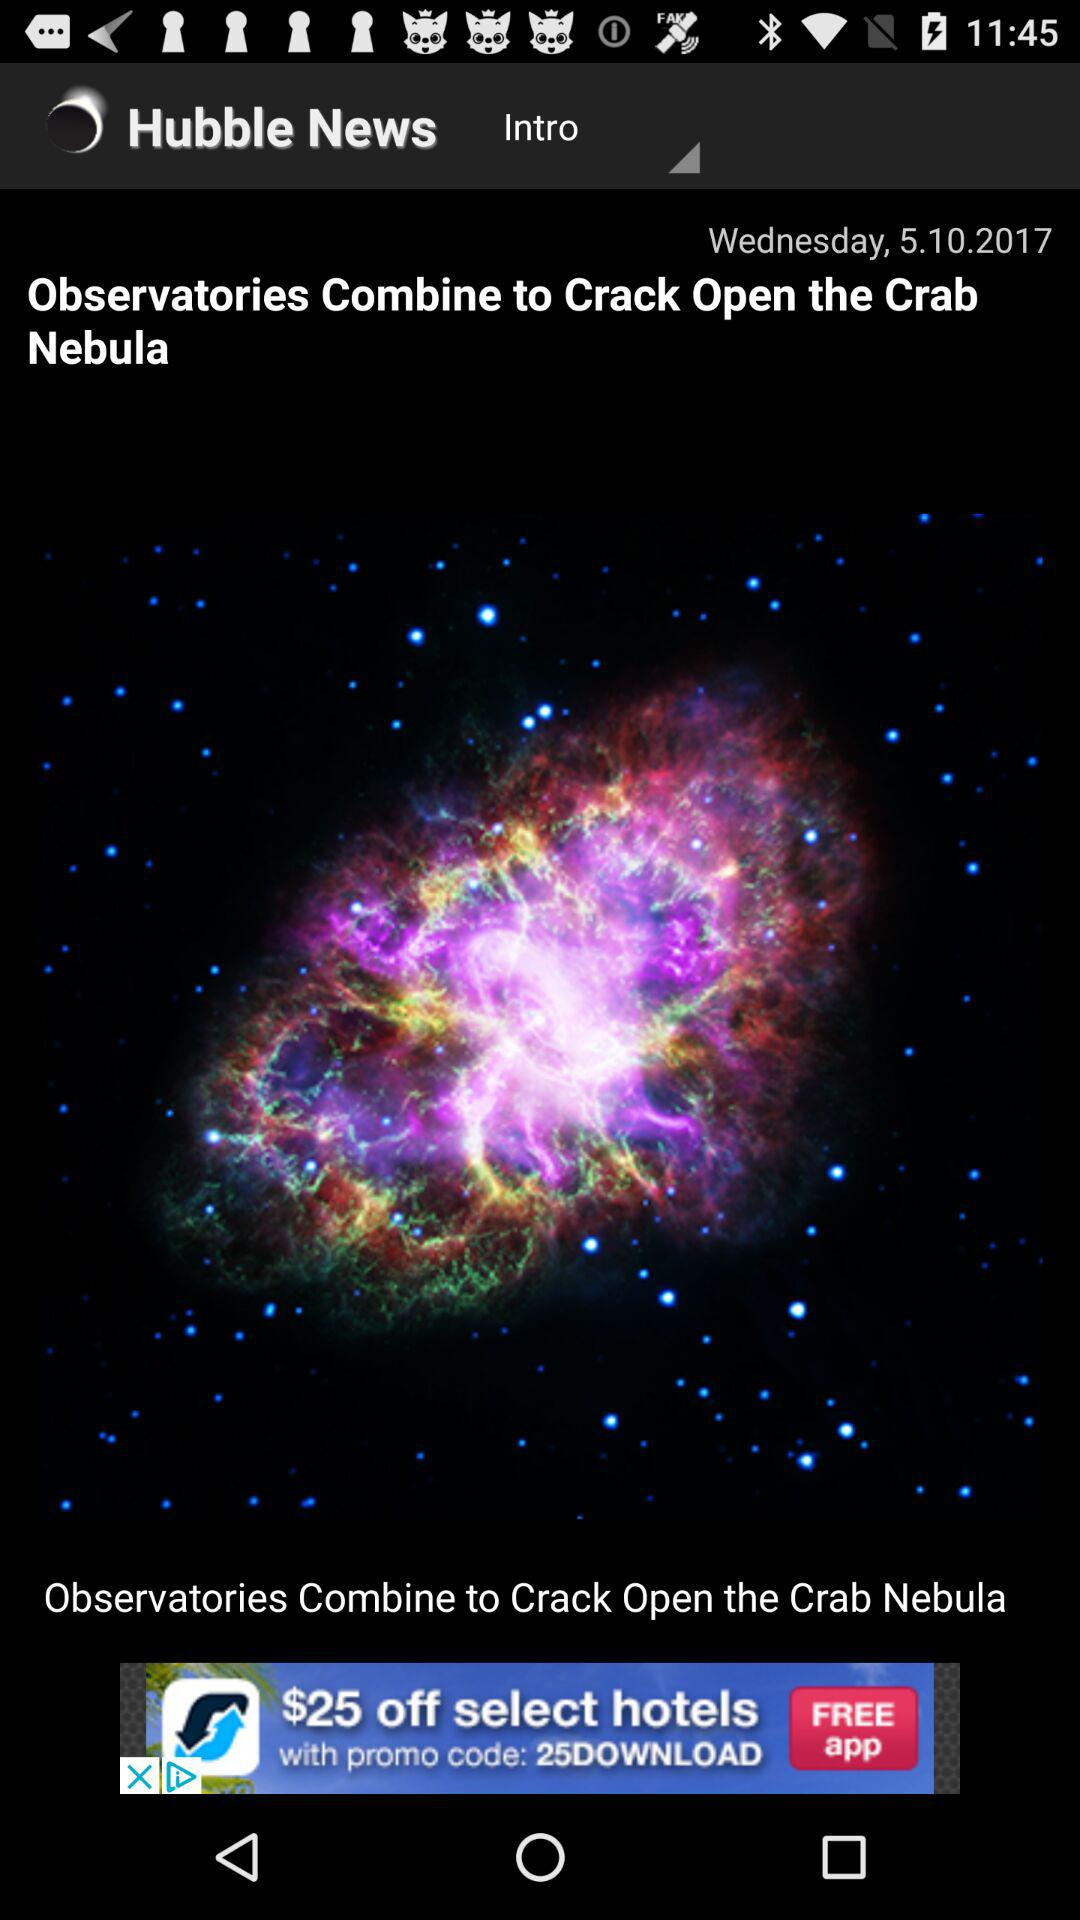What date is shown on the screen? The date shown on the screen is Wednesday, October 5, 2017. 